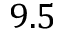Convert formula to latex. <formula><loc_0><loc_0><loc_500><loc_500>9 . 5</formula> 